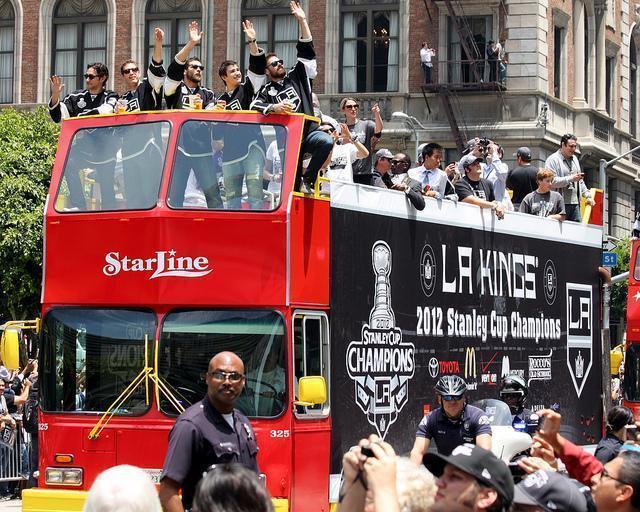What kind of team is this celebrating?
Indicate the correct response by choosing from the four available options to answer the question.
Options: Nfl football, mlb baseball, nhl hockey, nba basketball. Nhl hockey. 